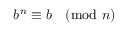Convert formula to latex. <formula><loc_0><loc_0><loc_500><loc_500>b ^ { n } \equiv b { \pmod { n } }</formula> 